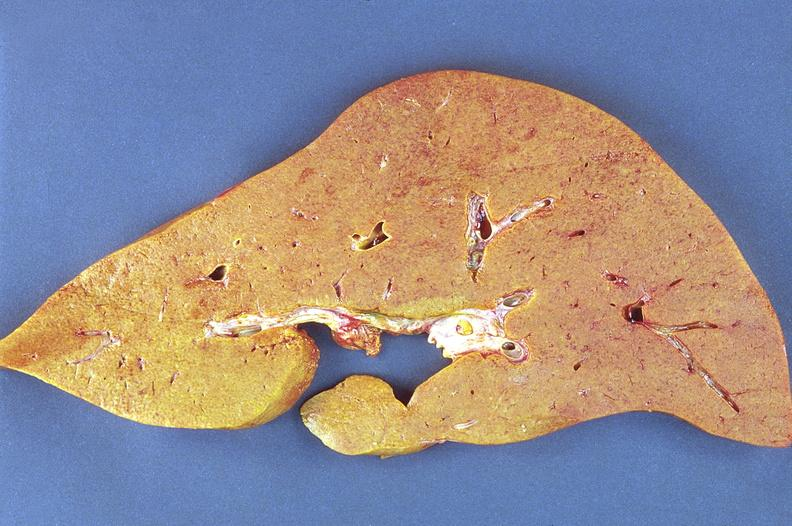does this image show amyloidosis?
Answer the question using a single word or phrase. Yes 